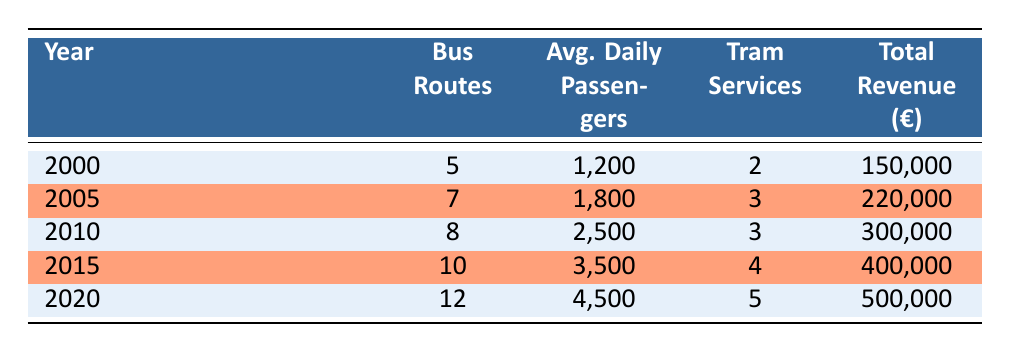What was the average daily number of passengers in 2010? Looking at the table, the value for average daily passengers in the year 2010 is directly listed as 2500.
Answer: 2500 How many bus routes were available in Lezo in 2005? The table indicates that in 2005, there were 7 bus routes.
Answer: 7 What was the total revenue in 2015? The total revenue for the year 2015, as listed in the table, is 400,000 euros.
Answer: 400,000 Did the number of tram services increase from 2000 to 2020? By checking the table, the number of tram services increased from 2 in 2000 to 5 in 2020, confirming that it did increase.
Answer: Yes What is the percentage increase in average daily passengers from 2000 to 2020? The average daily passengers in 2000 were 1200, and in 2020 they were 4500. The increase is 4500 - 1200 = 3300. To find the percentage increase, it is (3300/1200) * 100 = 275%.
Answer: 275% If the number of bus routes is directly correlated with total revenue, which year had the highest increase in revenue compared to the previous year? Examining the revenue change from year to year: 2000 to 2005 (70,000), 2005 to 2010 (80,000), 2010 to 2015 (100,000), and 2015 to 2020 (100,000). The largest increase was from 2010 to 2015 (100,000).
Answer: 2010 to 2015 How many total revenue euros were generated over all the years combined? Summing up the total revenue from each year: 150,000 + 220,000 + 300,000 + 400,000 + 500,000 = 1,570,000 euros was generated in total.
Answer: 1,570,000 Was the average number of daily passengers higher in 2010 than in 2005? From the table, 2010 shows 2500 average daily passengers while 2005 shows 1800, confirming that 2010 had a higher average.
Answer: Yes Which year saw the highest number of bus routes, and how many were there? According to the table, the year 2020 had the highest number of bus routes at 12.
Answer: 2020, 12 